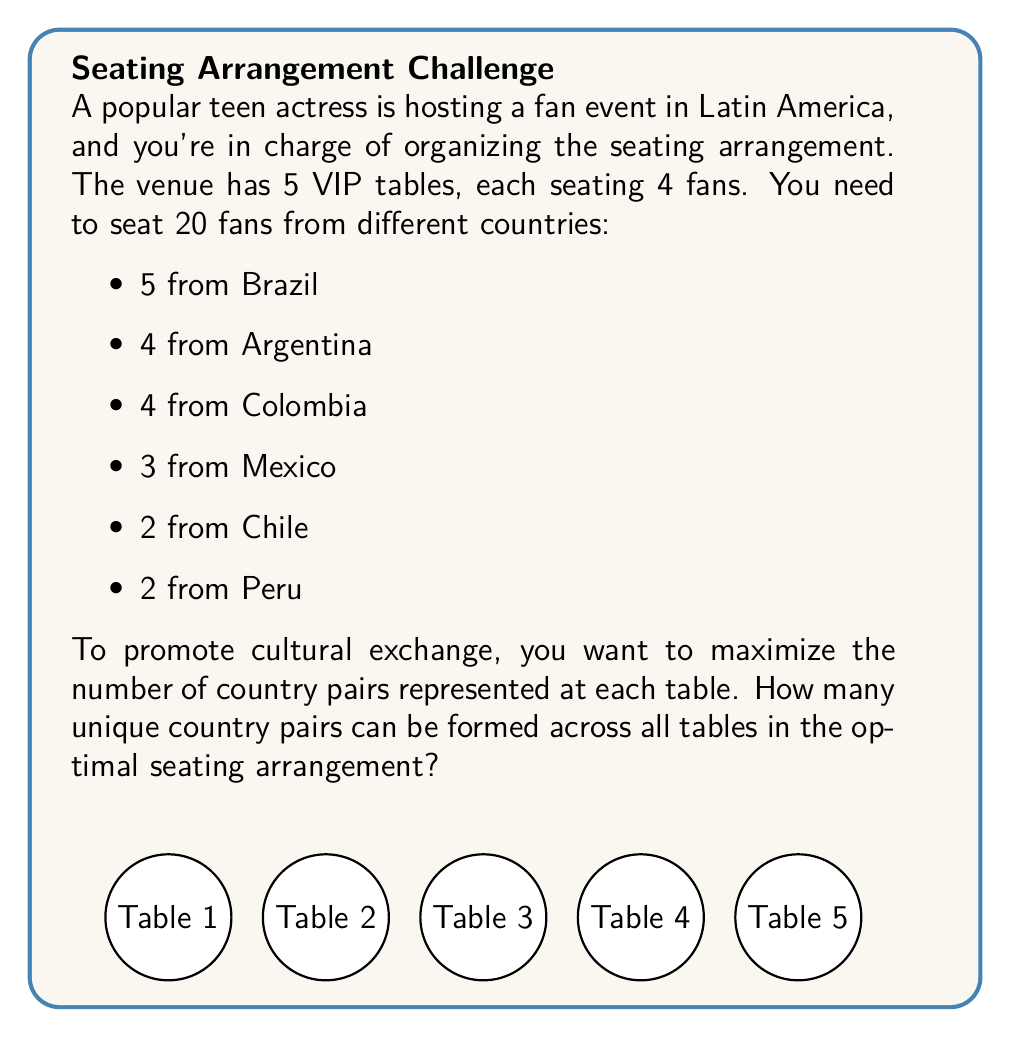Give your solution to this math problem. Let's approach this step-by-step using graph theory and combinatorics:

1) First, we need to understand what "country pairs" means. In each table, we can form $\binom{4}{2} = 6$ pairs of fans.

2) The maximum number of unique country pairs overall is $\binom{6}{2} = 15$, as there are 6 countries in total.

3) To maximize the number of unique pairs, we should try to distribute fans from different countries as evenly as possible across the tables.

4) One optimal arrangement could be:
   Table 1: Brazil, Argentina, Colombia, Mexico
   Table 2: Brazil, Argentina, Colombia, Chile
   Table 3: Brazil, Argentina, Colombia, Peru
   Table 4: Brazil, Argentina, Mexico, Peru
   Table 5: Brazil, Colombia, Mexico, Chile

5) Now, let's count the unique pairs in this arrangement:
   - Brazil-Argentina: 3 tables
   - Brazil-Colombia: 3 tables
   - Brazil-Mexico: 2 tables
   - Brazil-Chile: 1 table
   - Brazil-Peru: 1 table
   - Argentina-Colombia: 3 tables
   - Argentina-Mexico: 1 table
   - Argentina-Chile: 1 table
   - Argentina-Peru: 1 table
   - Colombia-Mexico: 1 table
   - Colombia-Chile: 1 table
   - Colombia-Peru: 1 table
   - Mexico-Peru: 1 table
   - Mexico-Chile: 1 table
   - Chile-Peru: 0 tables

6) Counting the unique pairs, we get 14 out of the possible 15 pairs.

7) It's impossible to achieve all 15 pairs because we can't seat fans from all 6 countries at one table (tables only seat 4).

Therefore, the maximum number of unique country pairs that can be formed across all tables is 14.
Answer: 14 unique country pairs 